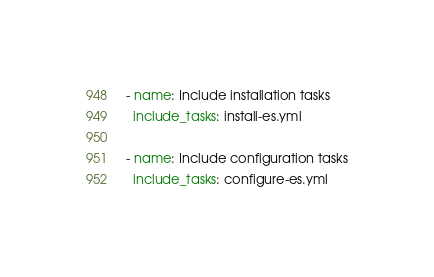<code> <loc_0><loc_0><loc_500><loc_500><_YAML_>- name: Include installation tasks
  include_tasks: install-es.yml

- name: Include configuration tasks
  include_tasks: configure-es.yml
</code> 